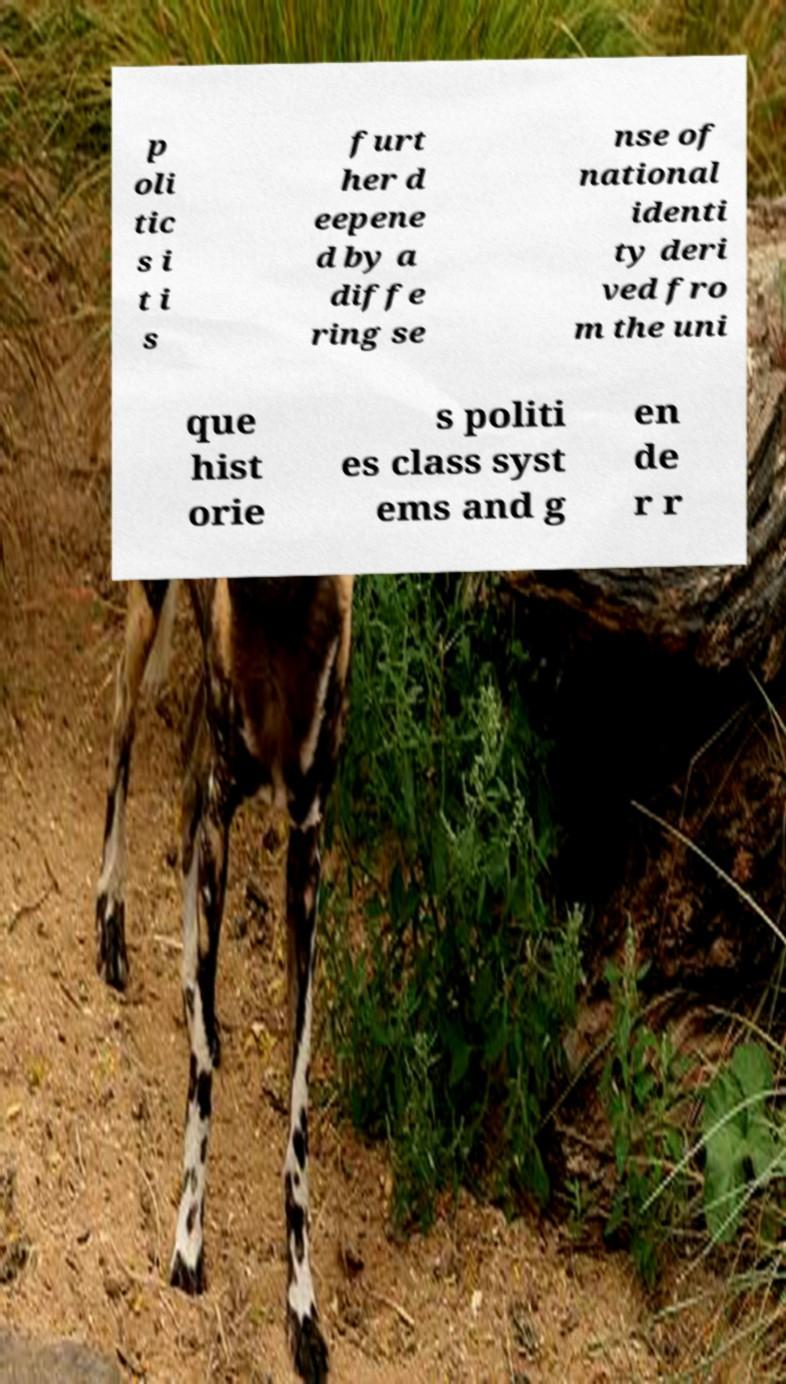Can you accurately transcribe the text from the provided image for me? p oli tic s i t i s furt her d eepene d by a diffe ring se nse of national identi ty deri ved fro m the uni que hist orie s politi es class syst ems and g en de r r 